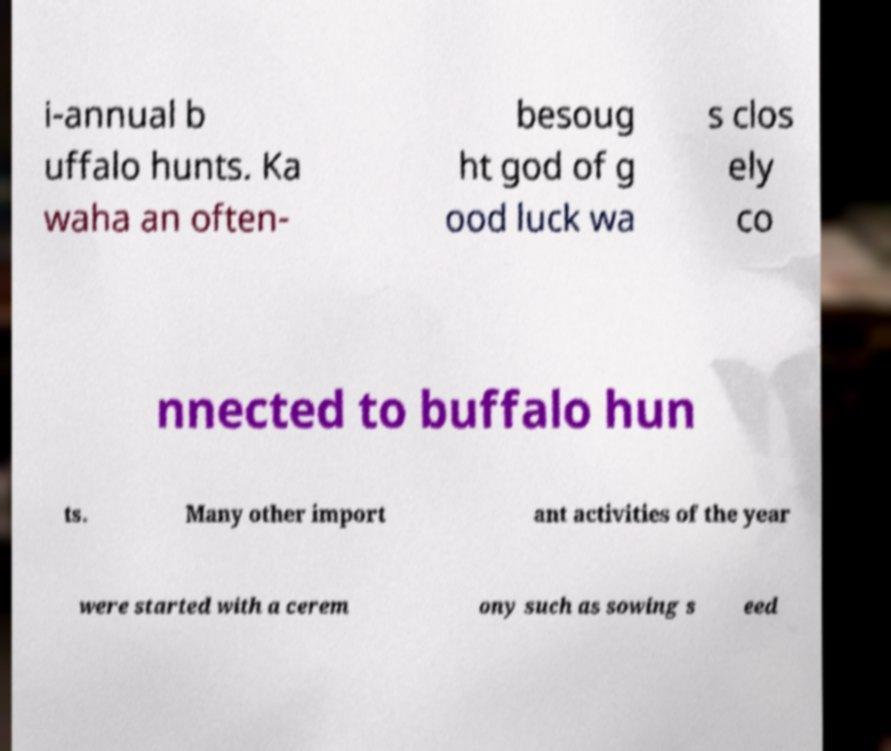What messages or text are displayed in this image? I need them in a readable, typed format. i-annual b uffalo hunts. Ka waha an often- besoug ht god of g ood luck wa s clos ely co nnected to buffalo hun ts. Many other import ant activities of the year were started with a cerem ony such as sowing s eed 